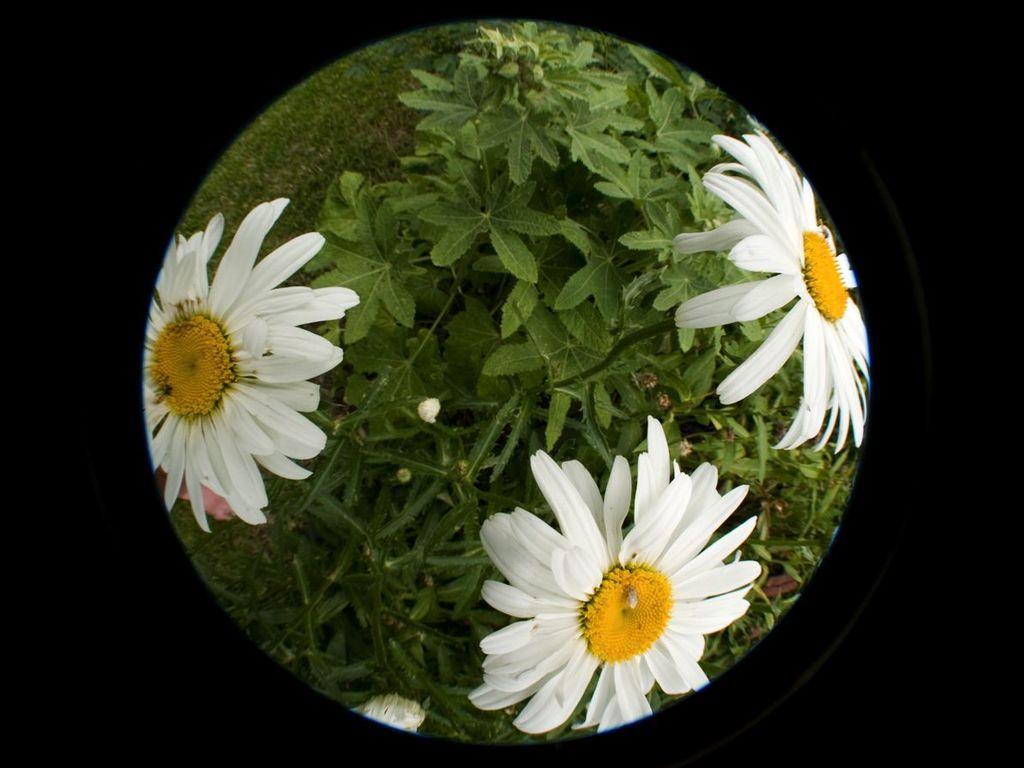Can you describe this image briefly? This looks like an edited image. I can see a plant with three white flowers. This is the grass. 